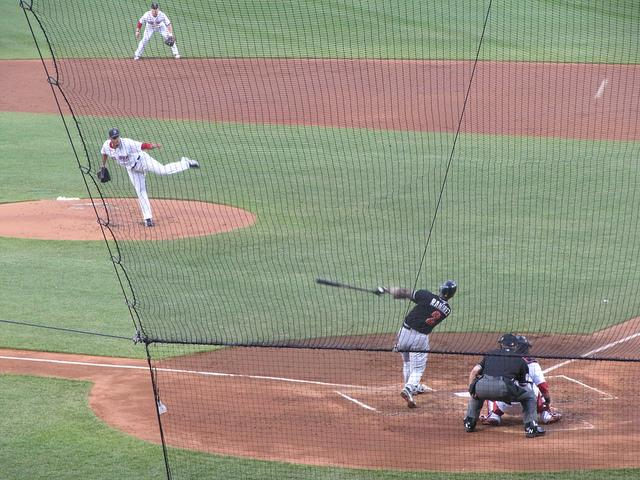What is the position of the player in the middle of the field? Please explain your reasoning. pitcher. The player in the middle of the field is pitching the ball. 